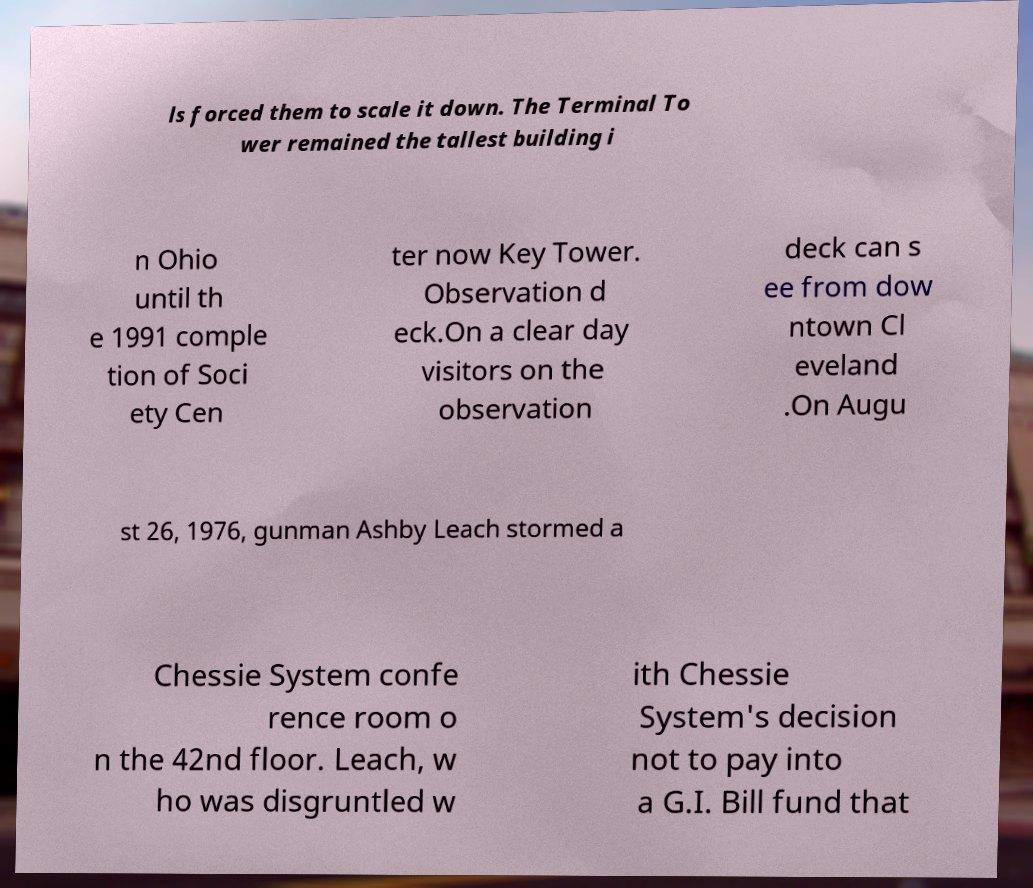Can you accurately transcribe the text from the provided image for me? ls forced them to scale it down. The Terminal To wer remained the tallest building i n Ohio until th e 1991 comple tion of Soci ety Cen ter now Key Tower. Observation d eck.On a clear day visitors on the observation deck can s ee from dow ntown Cl eveland .On Augu st 26, 1976, gunman Ashby Leach stormed a Chessie System confe rence room o n the 42nd floor. Leach, w ho was disgruntled w ith Chessie System's decision not to pay into a G.I. Bill fund that 